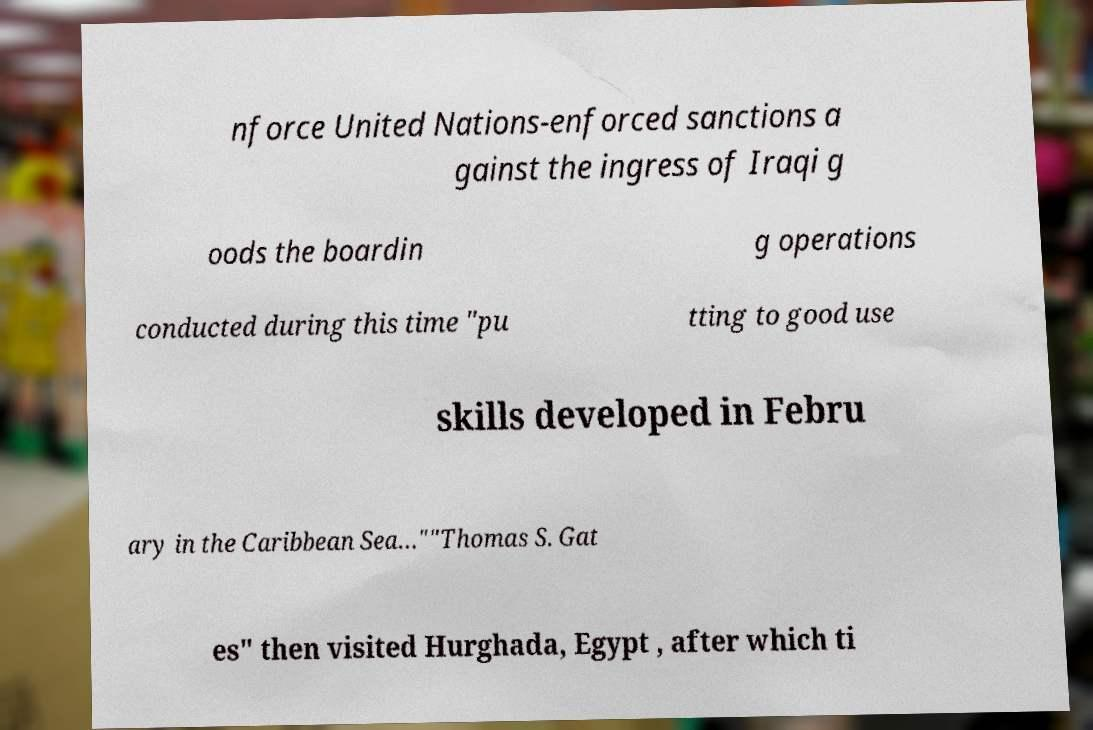I need the written content from this picture converted into text. Can you do that? nforce United Nations-enforced sanctions a gainst the ingress of Iraqi g oods the boardin g operations conducted during this time "pu tting to good use skills developed in Febru ary in the Caribbean Sea…""Thomas S. Gat es" then visited Hurghada, Egypt , after which ti 